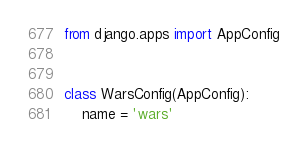<code> <loc_0><loc_0><loc_500><loc_500><_Python_>from django.apps import AppConfig


class WarsConfig(AppConfig):
    name = 'wars'
</code> 